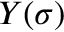Convert formula to latex. <formula><loc_0><loc_0><loc_500><loc_500>Y ( \sigma )</formula> 